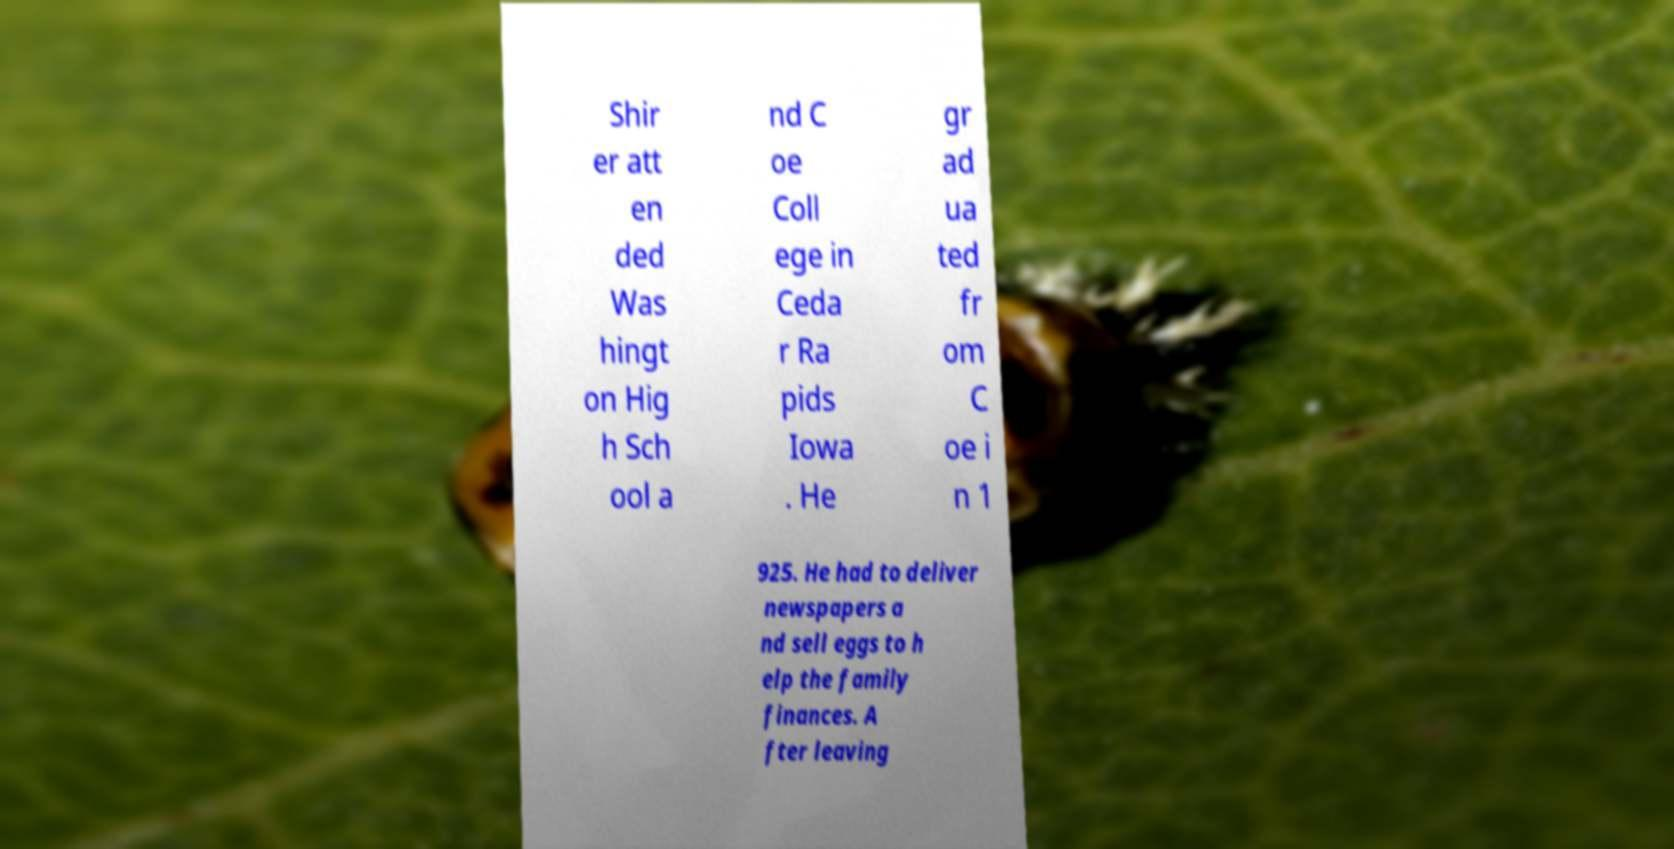For documentation purposes, I need the text within this image transcribed. Could you provide that? Shir er att en ded Was hingt on Hig h Sch ool a nd C oe Coll ege in Ceda r Ra pids Iowa . He gr ad ua ted fr om C oe i n 1 925. He had to deliver newspapers a nd sell eggs to h elp the family finances. A fter leaving 